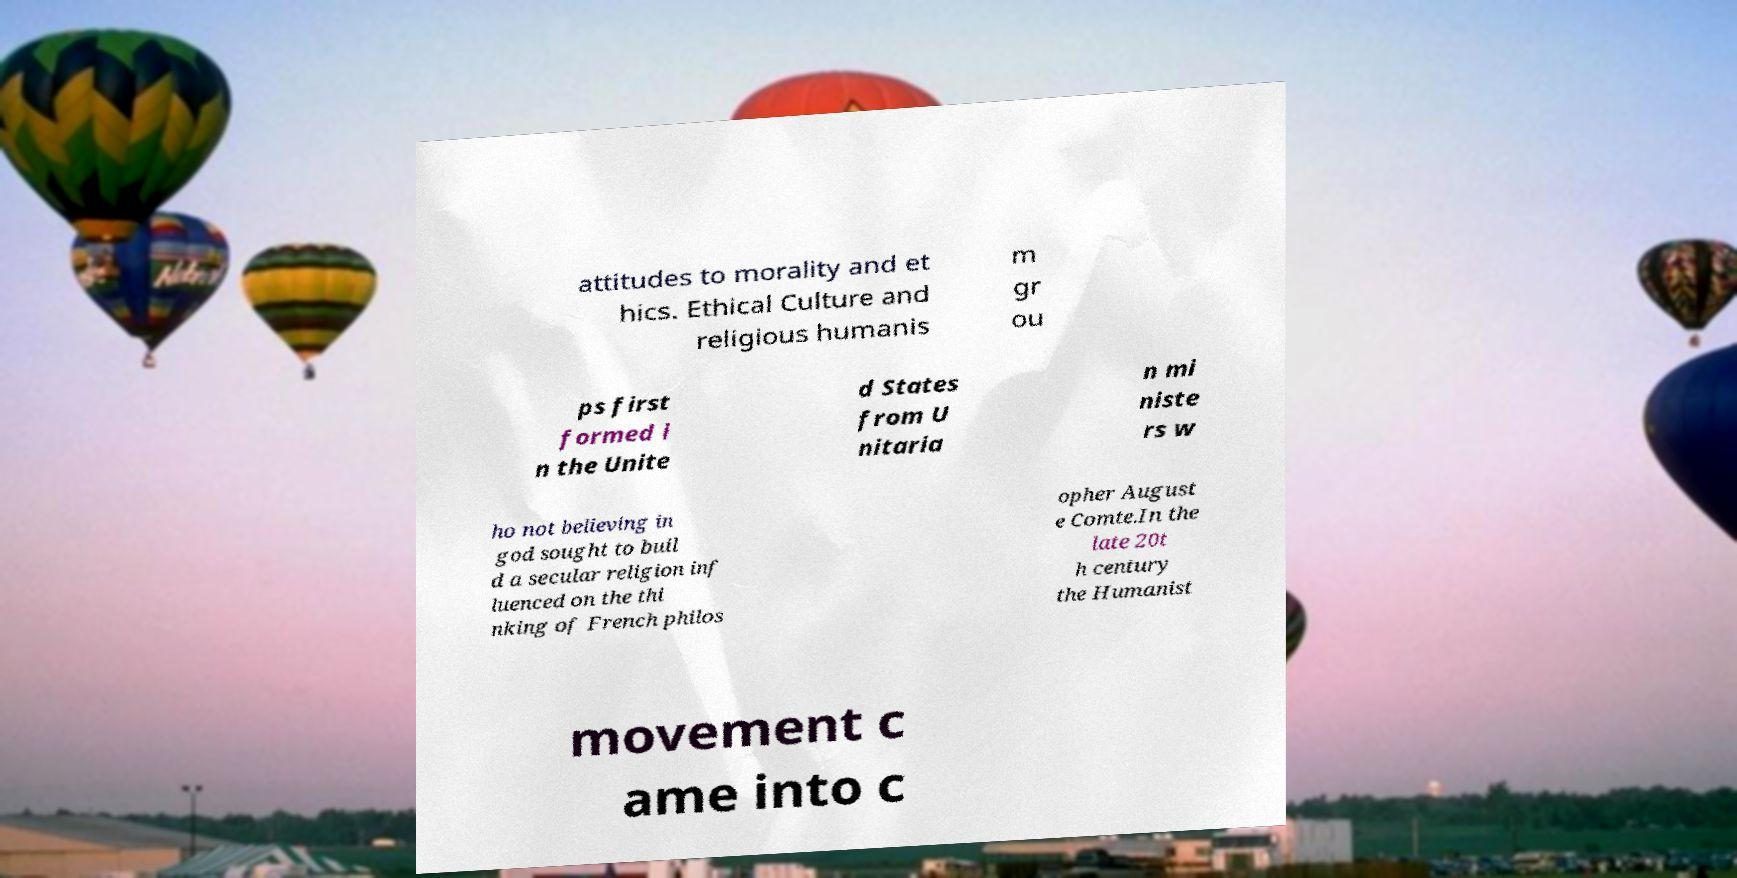I need the written content from this picture converted into text. Can you do that? attitudes to morality and et hics. Ethical Culture and religious humanis m gr ou ps first formed i n the Unite d States from U nitaria n mi niste rs w ho not believing in god sought to buil d a secular religion inf luenced on the thi nking of French philos opher August e Comte.In the late 20t h century the Humanist movement c ame into c 